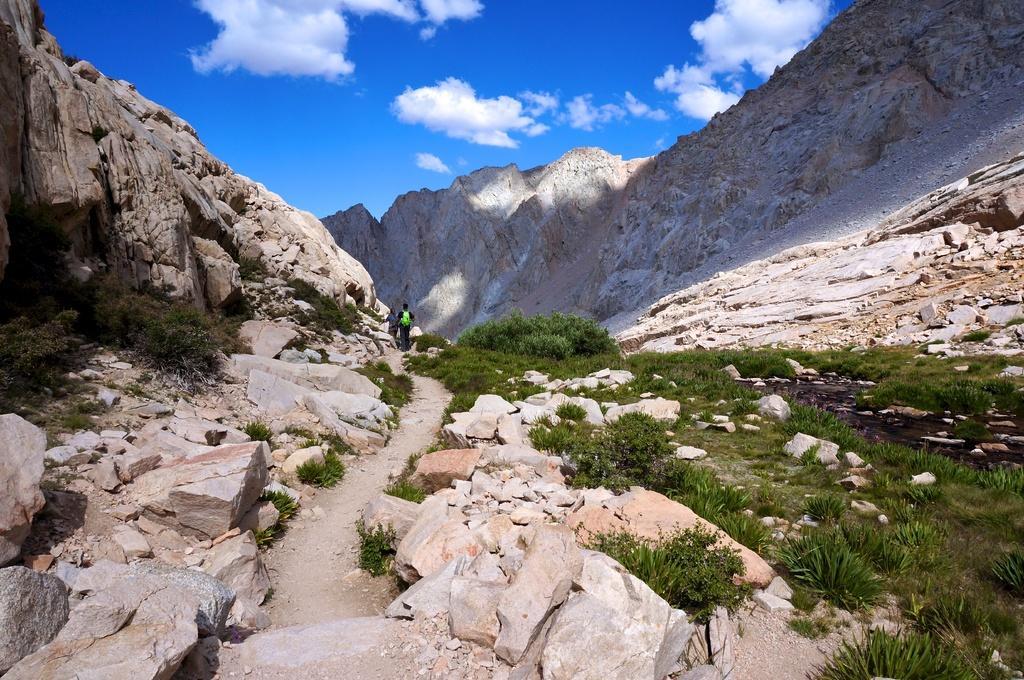Please provide a concise description of this image. In this picture there is a man who is wearing bag, t-shirt, trouser and shoe. He is standing near to the stones. In the background we can see mountains. At the top we can see sky and clouds. At the bottom we can see plants, grass and stones. On the right there is a water. 